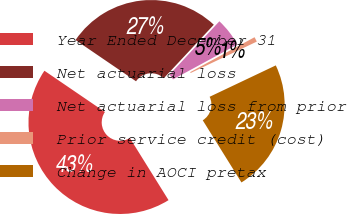Convert chart. <chart><loc_0><loc_0><loc_500><loc_500><pie_chart><fcel>Year Ended December 31<fcel>Net actuarial loss<fcel>Net actuarial loss from prior<fcel>Prior service credit (cost)<fcel>Change in AOCI pretax<nl><fcel>43.39%<fcel>27.44%<fcel>5.12%<fcel>0.86%<fcel>23.19%<nl></chart> 